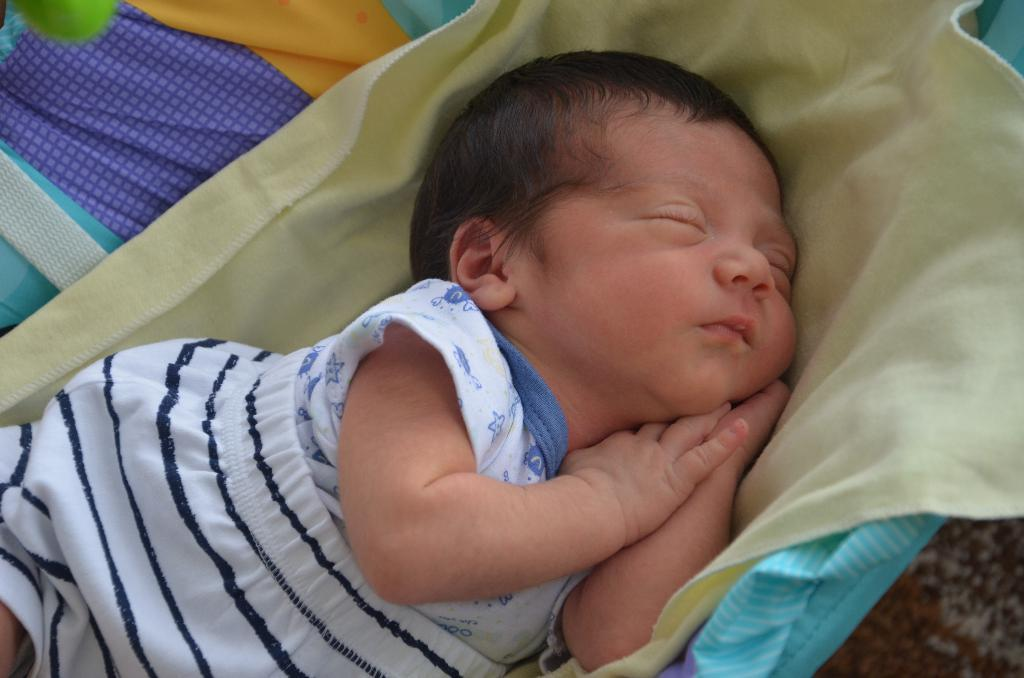What is the main subject of the image? The main subject of the image is a baby sleeping on a blanket. Can you describe the baby's surroundings? In the background of the image, there are clothes visible. How many friends are sitting on the chairs in the image? There are no chairs or friends present in the image; it features a baby sleeping on a blanket with clothes in the background. 